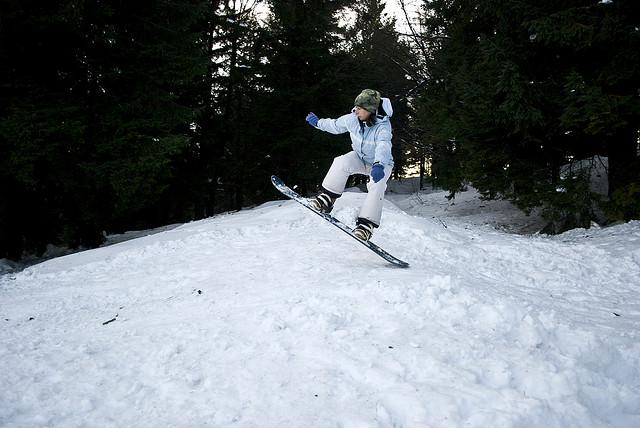What color are her gloves?
Be succinct. Blue. What does this person have on their feet?
Write a very short answer. Snowboard. What are the green things called behind the person?
Quick response, please. Trees. 